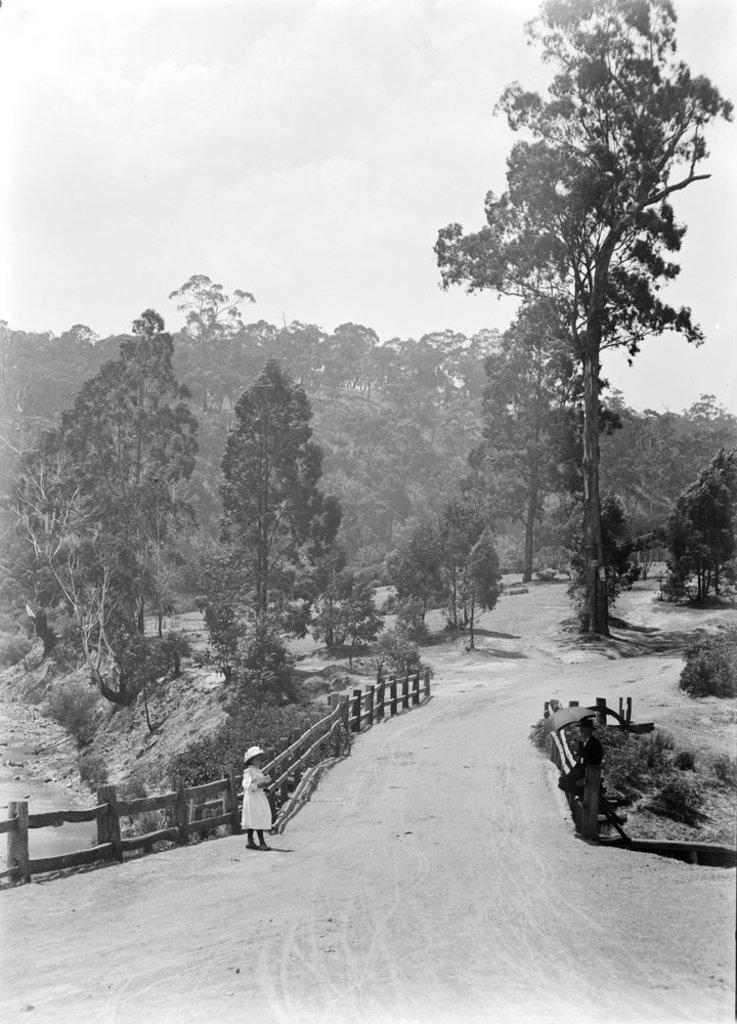What can be seen beside the road in the image? There are people standing beside the road in the image. What is present on one side of the road? There is fencing on one side of the road. What type of natural elements can be seen around the area? There are trees visible around the area. What page of the book is the beast reading in the image? There is no book or beast present in the image. What things are the people holding in the image? The provided facts do not mention any specific things that the people are holding. 